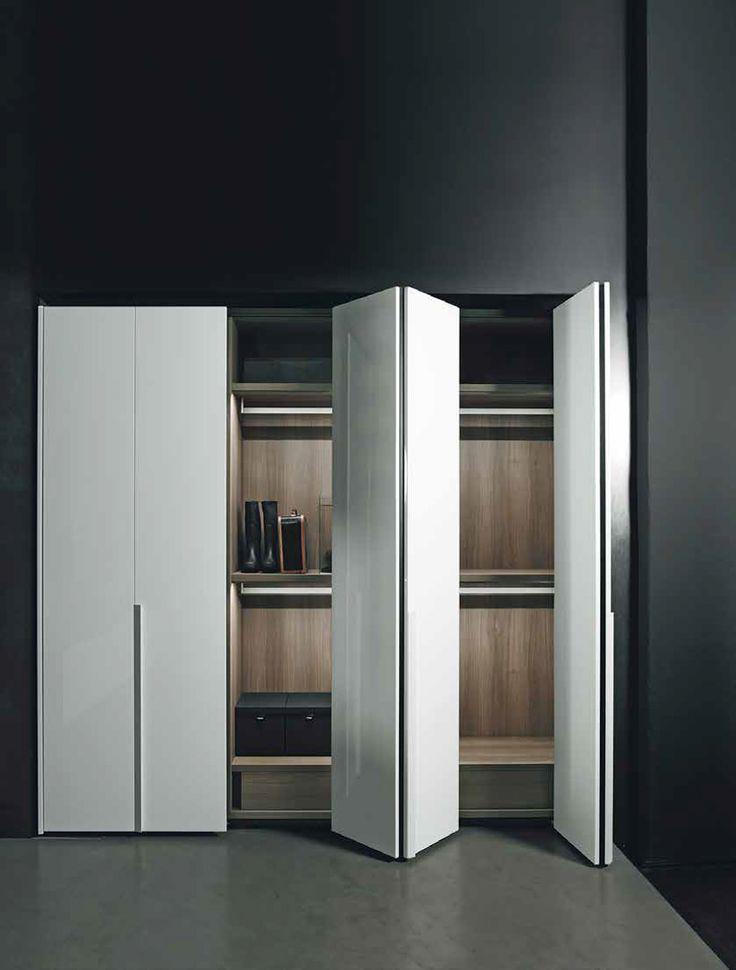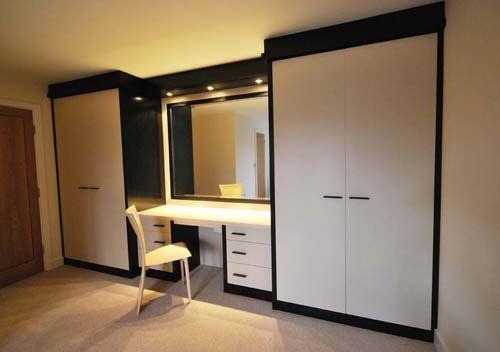The first image is the image on the left, the second image is the image on the right. Analyze the images presented: Is the assertion "An image shows a wardrobe with partly open doors revealing items and shelves inside." valid? Answer yes or no. Yes. 